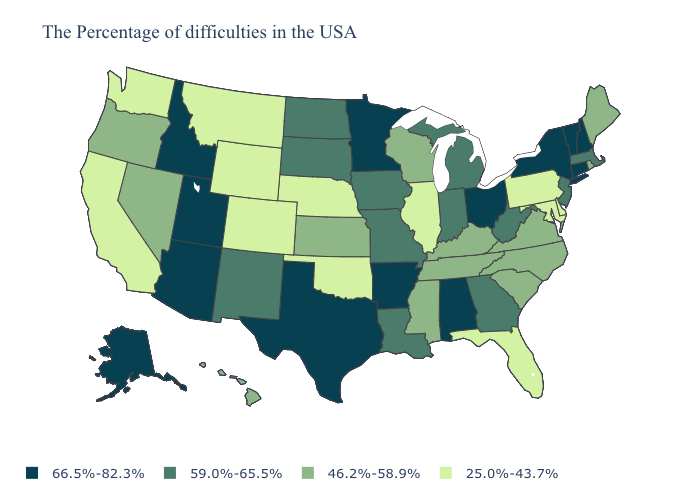Does Oregon have a higher value than Texas?
Keep it brief. No. Name the states that have a value in the range 66.5%-82.3%?
Keep it brief. New Hampshire, Vermont, Connecticut, New York, Ohio, Alabama, Arkansas, Minnesota, Texas, Utah, Arizona, Idaho, Alaska. What is the highest value in the West ?
Concise answer only. 66.5%-82.3%. What is the value of Montana?
Give a very brief answer. 25.0%-43.7%. Name the states that have a value in the range 59.0%-65.5%?
Answer briefly. Massachusetts, New Jersey, West Virginia, Georgia, Michigan, Indiana, Louisiana, Missouri, Iowa, South Dakota, North Dakota, New Mexico. Is the legend a continuous bar?
Write a very short answer. No. Name the states that have a value in the range 59.0%-65.5%?
Keep it brief. Massachusetts, New Jersey, West Virginia, Georgia, Michigan, Indiana, Louisiana, Missouri, Iowa, South Dakota, North Dakota, New Mexico. What is the value of North Carolina?
Write a very short answer. 46.2%-58.9%. What is the highest value in the South ?
Short answer required. 66.5%-82.3%. Does New York have the highest value in the Northeast?
Short answer required. Yes. What is the value of Texas?
Concise answer only. 66.5%-82.3%. What is the value of Missouri?
Concise answer only. 59.0%-65.5%. Among the states that border Kansas , does Oklahoma have the highest value?
Quick response, please. No. Does Idaho have the lowest value in the USA?
Quick response, please. No. 